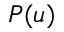Convert formula to latex. <formula><loc_0><loc_0><loc_500><loc_500>P ( u )</formula> 